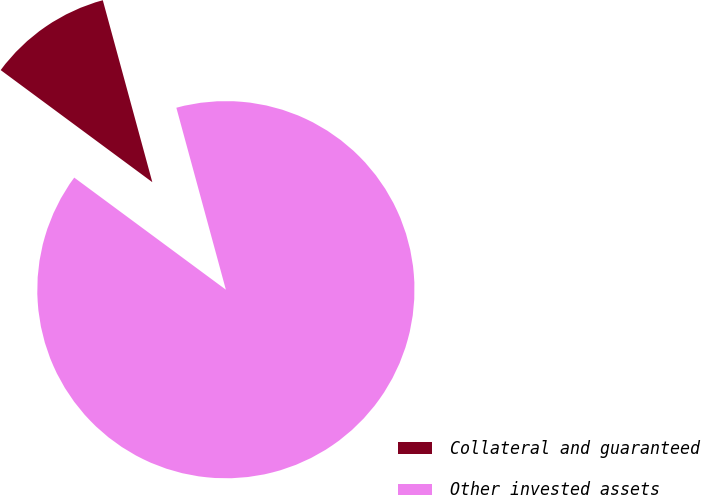Convert chart. <chart><loc_0><loc_0><loc_500><loc_500><pie_chart><fcel>Collateral and guaranteed<fcel>Other invested assets<nl><fcel>10.64%<fcel>89.36%<nl></chart> 